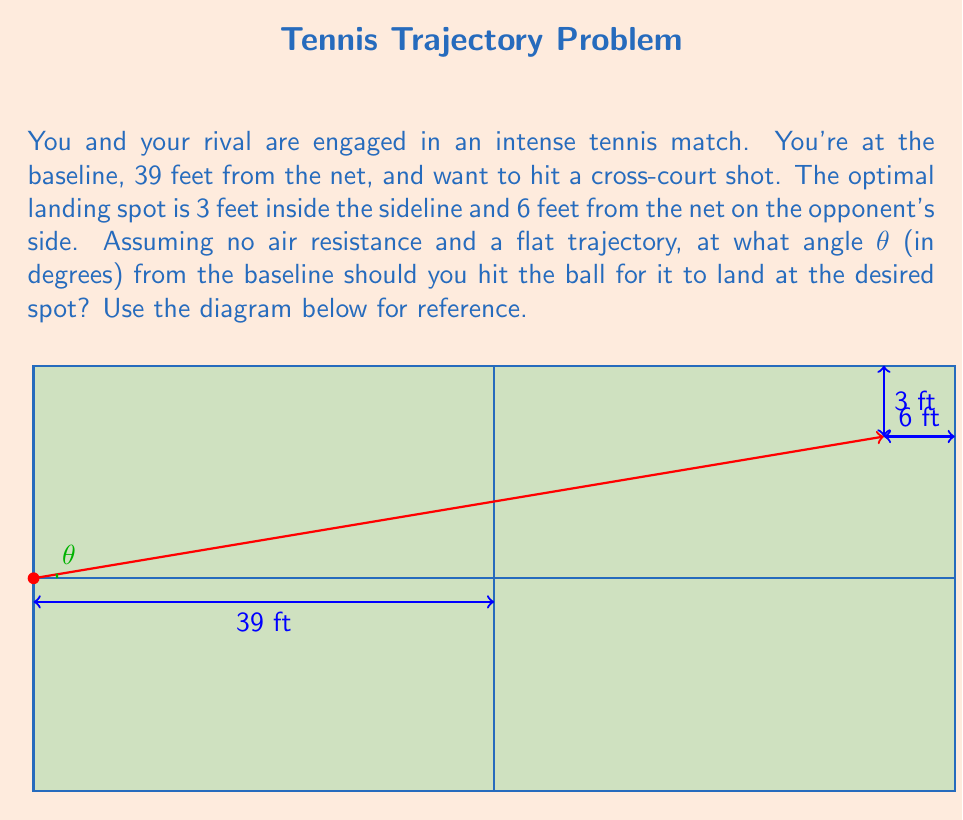Can you answer this question? Let's approach this step-by-step using trigonometry and vector analysis:

1) First, we need to determine the total horizontal and vertical distances the ball needs to travel.

   Horizontal distance: 39 ft (to net) + 72 ft (to landing spot) = 111 ft
   Vertical distance: 30 ft - 18 ft = 12 ft (court is 36 ft wide, so each half is 18 ft)

2) Now we can treat this as a right triangle problem, where:
   - The hypotenuse is the direct path of the ball
   - The base is the horizontal distance (111 ft)
   - The height is the vertical distance (12 ft)

3) To find the angle θ, we can use the arctangent function:

   $$θ = \arctan(\frac{\text{opposite}}{\text{adjacent}}) = \arctan(\frac{12}{111})$$

4) Let's calculate this:
   $$θ = \arctan(\frac{12}{111}) \approx 0.1078 \text{ radians}$$

5) Convert radians to degrees:
   $$θ = 0.1078 \times \frac{180°}{\pi} \approx 6.18°$$

Therefore, you should hit the ball at an angle of approximately 6.18° from the baseline to achieve the desired cross-court shot.
Answer: 6.18° 